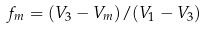Convert formula to latex. <formula><loc_0><loc_0><loc_500><loc_500>f _ { m } = ( V _ { 3 } - V _ { m } ) / ( V _ { 1 } - V _ { 3 } )</formula> 